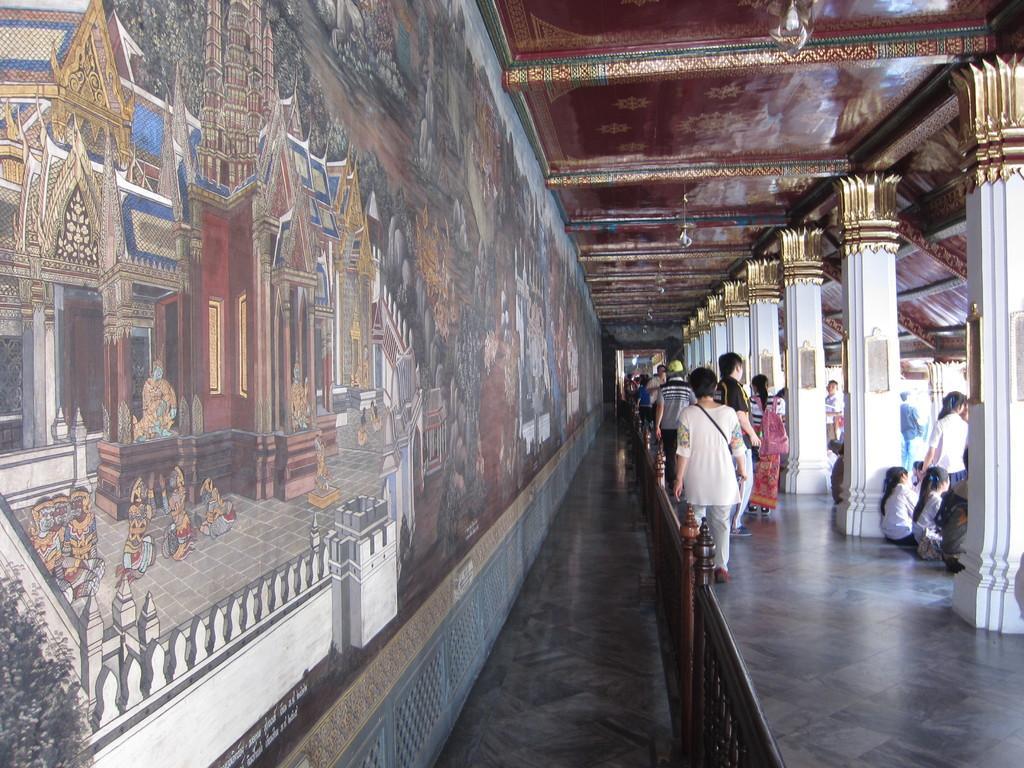In one or two sentences, can you explain what this image depicts? In this image there are few people walking on the floor. Beside them there is a wooden fence. On the left side there is a wall on which there are paintings. On the right side there are pillars one beside the other. At the top there is ceiling. 